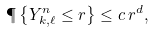Convert formula to latex. <formula><loc_0><loc_0><loc_500><loc_500>\P \left \{ Y _ { k , \ell } ^ { n } \leq r \right \} \leq c \, r ^ { d } ,</formula> 